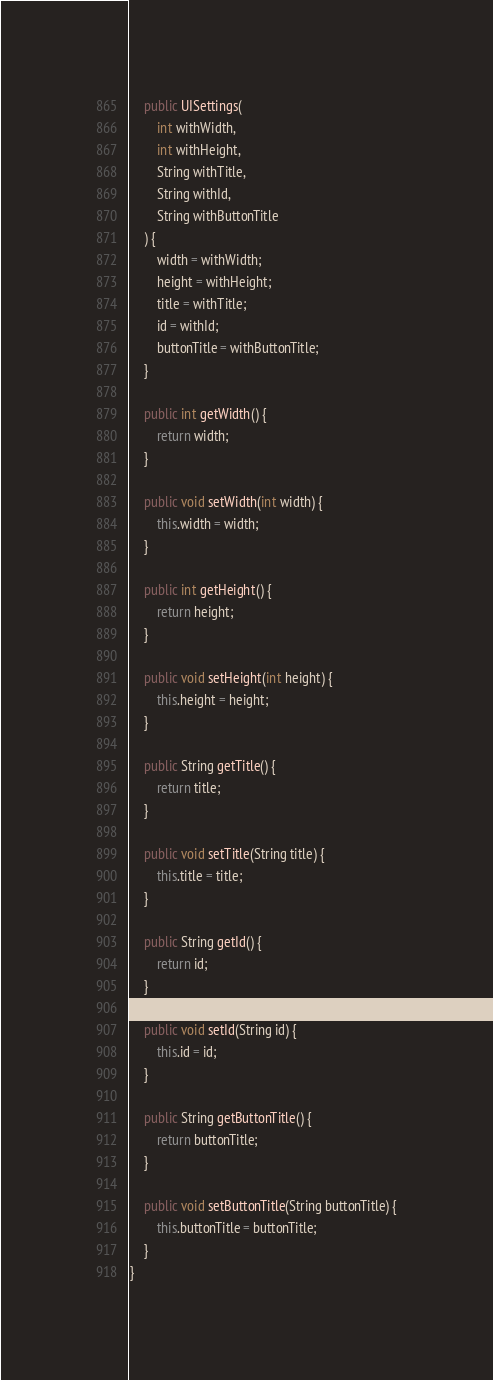Convert code to text. <code><loc_0><loc_0><loc_500><loc_500><_Java_>
    public UISettings(
        int withWidth,
        int withHeight,
        String withTitle,
        String withId,
        String withButtonTitle
    ) {
        width = withWidth;
        height = withHeight;
        title = withTitle;
        id = withId;
        buttonTitle = withButtonTitle;
    }

    public int getWidth() {
        return width;
    }

    public void setWidth(int width) {
        this.width = width;
    }

    public int getHeight() {
        return height;
    }

    public void setHeight(int height) {
        this.height = height;
    }

    public String getTitle() {
        return title;
    }

    public void setTitle(String title) {
        this.title = title;
    }

    public String getId() {
        return id;
    }

    public void setId(String id) {
        this.id = id;
    }

    public String getButtonTitle() {
        return buttonTitle;
    }

    public void setButtonTitle(String buttonTitle) {
        this.buttonTitle = buttonTitle;
    }
}
</code> 